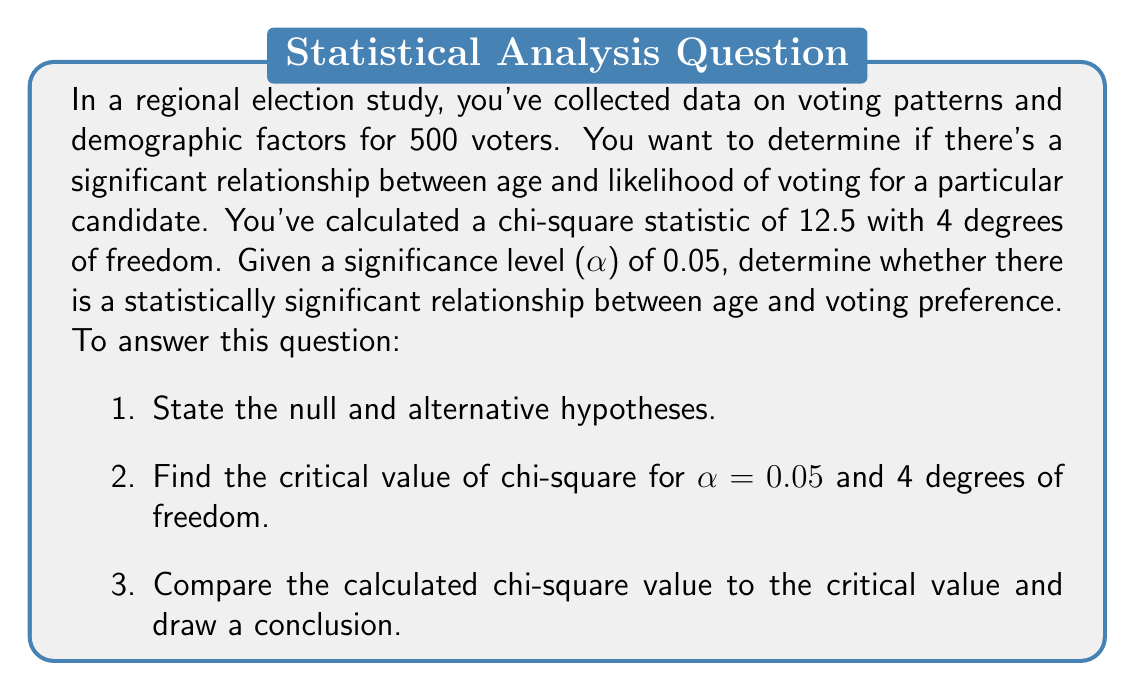Give your solution to this math problem. Let's approach this step-by-step:

1. State the hypotheses:
   - Null hypothesis ($H_0$): There is no significant relationship between age and voting preference.
   - Alternative hypothesis ($H_1$): There is a significant relationship between age and voting preference.

2. Find the critical value:
   - We need to find the critical value of chi-square for $\alpha = 0.05$ and 4 degrees of freedom.
   - Using a chi-square distribution table or calculator, we find:
     $$\chi^2_{critical} = 9.488$$

3. Compare and conclude:
   - Our calculated chi-square value is 12.5
   - We reject the null hypothesis if $\chi^2_{calculated} > \chi^2_{critical}$
   
   Since $12.5 > 9.488$, we reject the null hypothesis.

The p-value for this test can be calculated:
$$p = P(\chi^2 > 12.5) \approx 0.014$$

This p-value is less than our significance level of 0.05, confirming our decision to reject the null hypothesis.
Answer: Reject the null hypothesis. There is statistically significant evidence at the $\alpha = 0.05$ level to conclude that there is a relationship between age and voting preference in this regional election study. 